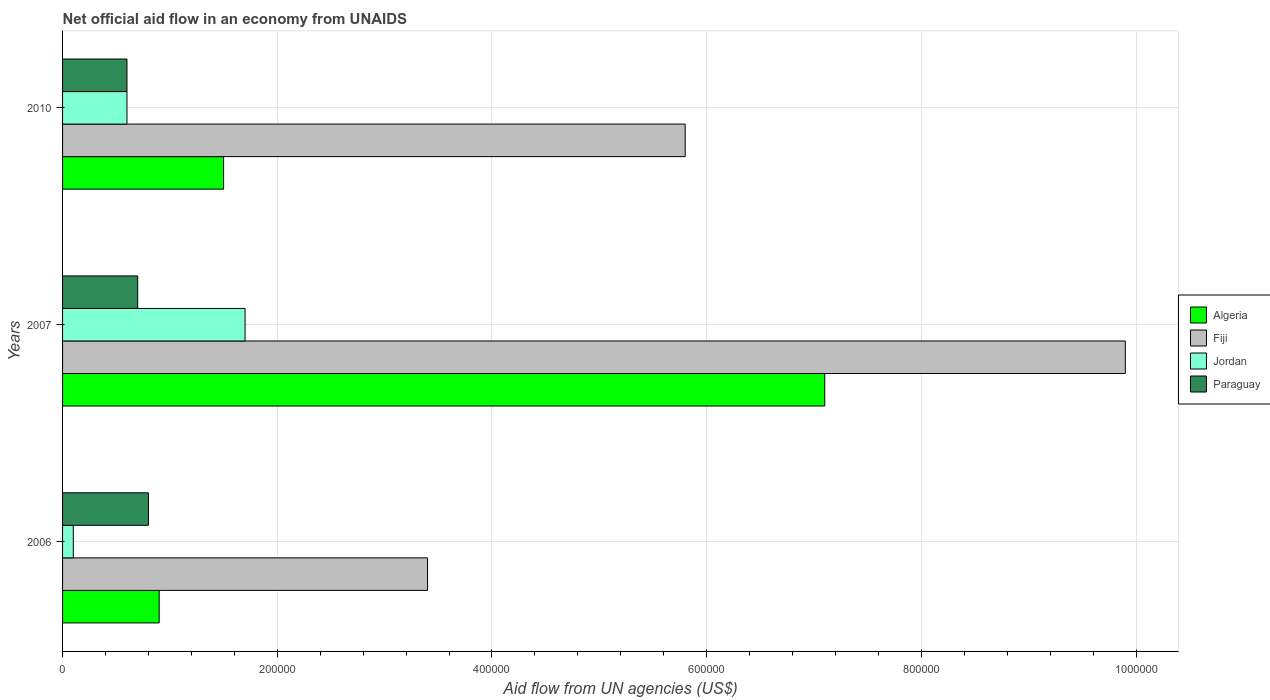How many groups of bars are there?
Provide a succinct answer. 3. Are the number of bars on each tick of the Y-axis equal?
Provide a short and direct response. Yes. How many bars are there on the 1st tick from the top?
Provide a succinct answer. 4. How many bars are there on the 2nd tick from the bottom?
Give a very brief answer. 4. What is the label of the 2nd group of bars from the top?
Offer a terse response. 2007. What is the net official aid flow in Paraguay in 2010?
Your answer should be very brief. 6.00e+04. Across all years, what is the maximum net official aid flow in Algeria?
Provide a succinct answer. 7.10e+05. Across all years, what is the minimum net official aid flow in Fiji?
Give a very brief answer. 3.40e+05. In which year was the net official aid flow in Algeria maximum?
Ensure brevity in your answer.  2007. In which year was the net official aid flow in Paraguay minimum?
Offer a very short reply. 2010. What is the total net official aid flow in Fiji in the graph?
Your answer should be compact. 1.91e+06. What is the difference between the net official aid flow in Algeria in 2006 and that in 2007?
Offer a terse response. -6.20e+05. What is the difference between the net official aid flow in Fiji in 2010 and the net official aid flow in Algeria in 2006?
Offer a very short reply. 4.90e+05. What is the average net official aid flow in Algeria per year?
Make the answer very short. 3.17e+05. In how many years, is the net official aid flow in Fiji greater than 720000 US$?
Your answer should be very brief. 1. What is the ratio of the net official aid flow in Paraguay in 2007 to that in 2010?
Provide a short and direct response. 1.17. What is the difference between the highest and the second highest net official aid flow in Fiji?
Offer a very short reply. 4.10e+05. What is the difference between the highest and the lowest net official aid flow in Jordan?
Offer a very short reply. 1.60e+05. Is the sum of the net official aid flow in Fiji in 2006 and 2007 greater than the maximum net official aid flow in Jordan across all years?
Your answer should be compact. Yes. Is it the case that in every year, the sum of the net official aid flow in Algeria and net official aid flow in Paraguay is greater than the sum of net official aid flow in Fiji and net official aid flow in Jordan?
Provide a short and direct response. No. What does the 2nd bar from the top in 2010 represents?
Give a very brief answer. Jordan. What does the 2nd bar from the bottom in 2007 represents?
Provide a short and direct response. Fiji. Are all the bars in the graph horizontal?
Provide a short and direct response. Yes. How many years are there in the graph?
Give a very brief answer. 3. Does the graph contain any zero values?
Your response must be concise. No. Where does the legend appear in the graph?
Your response must be concise. Center right. How many legend labels are there?
Your answer should be compact. 4. What is the title of the graph?
Ensure brevity in your answer.  Net official aid flow in an economy from UNAIDS. What is the label or title of the X-axis?
Offer a very short reply. Aid flow from UN agencies (US$). What is the label or title of the Y-axis?
Ensure brevity in your answer.  Years. What is the Aid flow from UN agencies (US$) in Fiji in 2006?
Your answer should be compact. 3.40e+05. What is the Aid flow from UN agencies (US$) of Jordan in 2006?
Your answer should be compact. 10000. What is the Aid flow from UN agencies (US$) in Paraguay in 2006?
Your response must be concise. 8.00e+04. What is the Aid flow from UN agencies (US$) of Algeria in 2007?
Provide a short and direct response. 7.10e+05. What is the Aid flow from UN agencies (US$) of Fiji in 2007?
Your response must be concise. 9.90e+05. What is the Aid flow from UN agencies (US$) in Jordan in 2007?
Make the answer very short. 1.70e+05. What is the Aid flow from UN agencies (US$) in Algeria in 2010?
Ensure brevity in your answer.  1.50e+05. What is the Aid flow from UN agencies (US$) in Fiji in 2010?
Provide a succinct answer. 5.80e+05. What is the Aid flow from UN agencies (US$) in Jordan in 2010?
Your answer should be compact. 6.00e+04. Across all years, what is the maximum Aid flow from UN agencies (US$) in Algeria?
Offer a terse response. 7.10e+05. Across all years, what is the maximum Aid flow from UN agencies (US$) in Fiji?
Keep it short and to the point. 9.90e+05. Across all years, what is the maximum Aid flow from UN agencies (US$) of Jordan?
Your answer should be very brief. 1.70e+05. Across all years, what is the maximum Aid flow from UN agencies (US$) in Paraguay?
Provide a short and direct response. 8.00e+04. Across all years, what is the minimum Aid flow from UN agencies (US$) in Algeria?
Ensure brevity in your answer.  9.00e+04. What is the total Aid flow from UN agencies (US$) in Algeria in the graph?
Ensure brevity in your answer.  9.50e+05. What is the total Aid flow from UN agencies (US$) in Fiji in the graph?
Make the answer very short. 1.91e+06. What is the total Aid flow from UN agencies (US$) in Jordan in the graph?
Your answer should be very brief. 2.40e+05. What is the total Aid flow from UN agencies (US$) of Paraguay in the graph?
Keep it short and to the point. 2.10e+05. What is the difference between the Aid flow from UN agencies (US$) in Algeria in 2006 and that in 2007?
Keep it short and to the point. -6.20e+05. What is the difference between the Aid flow from UN agencies (US$) in Fiji in 2006 and that in 2007?
Your response must be concise. -6.50e+05. What is the difference between the Aid flow from UN agencies (US$) in Paraguay in 2006 and that in 2007?
Your response must be concise. 10000. What is the difference between the Aid flow from UN agencies (US$) of Fiji in 2006 and that in 2010?
Ensure brevity in your answer.  -2.40e+05. What is the difference between the Aid flow from UN agencies (US$) of Jordan in 2006 and that in 2010?
Ensure brevity in your answer.  -5.00e+04. What is the difference between the Aid flow from UN agencies (US$) in Algeria in 2007 and that in 2010?
Offer a very short reply. 5.60e+05. What is the difference between the Aid flow from UN agencies (US$) of Algeria in 2006 and the Aid flow from UN agencies (US$) of Fiji in 2007?
Ensure brevity in your answer.  -9.00e+05. What is the difference between the Aid flow from UN agencies (US$) in Algeria in 2006 and the Aid flow from UN agencies (US$) in Jordan in 2007?
Your answer should be compact. -8.00e+04. What is the difference between the Aid flow from UN agencies (US$) in Algeria in 2006 and the Aid flow from UN agencies (US$) in Paraguay in 2007?
Your answer should be very brief. 2.00e+04. What is the difference between the Aid flow from UN agencies (US$) of Algeria in 2006 and the Aid flow from UN agencies (US$) of Fiji in 2010?
Ensure brevity in your answer.  -4.90e+05. What is the difference between the Aid flow from UN agencies (US$) of Algeria in 2006 and the Aid flow from UN agencies (US$) of Jordan in 2010?
Offer a terse response. 3.00e+04. What is the difference between the Aid flow from UN agencies (US$) in Fiji in 2006 and the Aid flow from UN agencies (US$) in Jordan in 2010?
Give a very brief answer. 2.80e+05. What is the difference between the Aid flow from UN agencies (US$) of Jordan in 2006 and the Aid flow from UN agencies (US$) of Paraguay in 2010?
Offer a very short reply. -5.00e+04. What is the difference between the Aid flow from UN agencies (US$) in Algeria in 2007 and the Aid flow from UN agencies (US$) in Jordan in 2010?
Your answer should be compact. 6.50e+05. What is the difference between the Aid flow from UN agencies (US$) of Algeria in 2007 and the Aid flow from UN agencies (US$) of Paraguay in 2010?
Your response must be concise. 6.50e+05. What is the difference between the Aid flow from UN agencies (US$) in Fiji in 2007 and the Aid flow from UN agencies (US$) in Jordan in 2010?
Give a very brief answer. 9.30e+05. What is the difference between the Aid flow from UN agencies (US$) of Fiji in 2007 and the Aid flow from UN agencies (US$) of Paraguay in 2010?
Keep it short and to the point. 9.30e+05. What is the difference between the Aid flow from UN agencies (US$) of Jordan in 2007 and the Aid flow from UN agencies (US$) of Paraguay in 2010?
Keep it short and to the point. 1.10e+05. What is the average Aid flow from UN agencies (US$) of Algeria per year?
Keep it short and to the point. 3.17e+05. What is the average Aid flow from UN agencies (US$) in Fiji per year?
Your answer should be compact. 6.37e+05. What is the average Aid flow from UN agencies (US$) of Jordan per year?
Keep it short and to the point. 8.00e+04. What is the average Aid flow from UN agencies (US$) of Paraguay per year?
Offer a very short reply. 7.00e+04. In the year 2006, what is the difference between the Aid flow from UN agencies (US$) in Fiji and Aid flow from UN agencies (US$) in Jordan?
Your response must be concise. 3.30e+05. In the year 2006, what is the difference between the Aid flow from UN agencies (US$) of Jordan and Aid flow from UN agencies (US$) of Paraguay?
Give a very brief answer. -7.00e+04. In the year 2007, what is the difference between the Aid flow from UN agencies (US$) of Algeria and Aid flow from UN agencies (US$) of Fiji?
Your answer should be compact. -2.80e+05. In the year 2007, what is the difference between the Aid flow from UN agencies (US$) of Algeria and Aid flow from UN agencies (US$) of Jordan?
Your answer should be very brief. 5.40e+05. In the year 2007, what is the difference between the Aid flow from UN agencies (US$) in Algeria and Aid flow from UN agencies (US$) in Paraguay?
Give a very brief answer. 6.40e+05. In the year 2007, what is the difference between the Aid flow from UN agencies (US$) in Fiji and Aid flow from UN agencies (US$) in Jordan?
Ensure brevity in your answer.  8.20e+05. In the year 2007, what is the difference between the Aid flow from UN agencies (US$) in Fiji and Aid flow from UN agencies (US$) in Paraguay?
Your answer should be compact. 9.20e+05. In the year 2007, what is the difference between the Aid flow from UN agencies (US$) of Jordan and Aid flow from UN agencies (US$) of Paraguay?
Offer a very short reply. 1.00e+05. In the year 2010, what is the difference between the Aid flow from UN agencies (US$) of Algeria and Aid flow from UN agencies (US$) of Fiji?
Make the answer very short. -4.30e+05. In the year 2010, what is the difference between the Aid flow from UN agencies (US$) in Fiji and Aid flow from UN agencies (US$) in Jordan?
Keep it short and to the point. 5.20e+05. In the year 2010, what is the difference between the Aid flow from UN agencies (US$) of Fiji and Aid flow from UN agencies (US$) of Paraguay?
Your response must be concise. 5.20e+05. What is the ratio of the Aid flow from UN agencies (US$) in Algeria in 2006 to that in 2007?
Ensure brevity in your answer.  0.13. What is the ratio of the Aid flow from UN agencies (US$) in Fiji in 2006 to that in 2007?
Keep it short and to the point. 0.34. What is the ratio of the Aid flow from UN agencies (US$) in Jordan in 2006 to that in 2007?
Offer a very short reply. 0.06. What is the ratio of the Aid flow from UN agencies (US$) of Fiji in 2006 to that in 2010?
Provide a short and direct response. 0.59. What is the ratio of the Aid flow from UN agencies (US$) of Paraguay in 2006 to that in 2010?
Your answer should be compact. 1.33. What is the ratio of the Aid flow from UN agencies (US$) of Algeria in 2007 to that in 2010?
Your response must be concise. 4.73. What is the ratio of the Aid flow from UN agencies (US$) in Fiji in 2007 to that in 2010?
Make the answer very short. 1.71. What is the ratio of the Aid flow from UN agencies (US$) of Jordan in 2007 to that in 2010?
Offer a very short reply. 2.83. What is the ratio of the Aid flow from UN agencies (US$) of Paraguay in 2007 to that in 2010?
Provide a short and direct response. 1.17. What is the difference between the highest and the second highest Aid flow from UN agencies (US$) in Algeria?
Provide a succinct answer. 5.60e+05. What is the difference between the highest and the second highest Aid flow from UN agencies (US$) in Fiji?
Offer a terse response. 4.10e+05. What is the difference between the highest and the second highest Aid flow from UN agencies (US$) in Jordan?
Offer a very short reply. 1.10e+05. What is the difference between the highest and the second highest Aid flow from UN agencies (US$) in Paraguay?
Make the answer very short. 10000. What is the difference between the highest and the lowest Aid flow from UN agencies (US$) of Algeria?
Keep it short and to the point. 6.20e+05. What is the difference between the highest and the lowest Aid flow from UN agencies (US$) in Fiji?
Offer a terse response. 6.50e+05. What is the difference between the highest and the lowest Aid flow from UN agencies (US$) in Jordan?
Give a very brief answer. 1.60e+05. What is the difference between the highest and the lowest Aid flow from UN agencies (US$) of Paraguay?
Keep it short and to the point. 2.00e+04. 